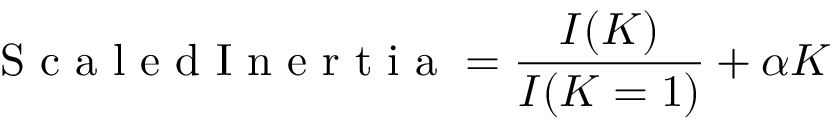Convert formula to latex. <formula><loc_0><loc_0><loc_500><loc_500>S c a l e d I n e r t i a = \frac { I ( K ) } { I ( K = 1 ) } + \alpha K</formula> 